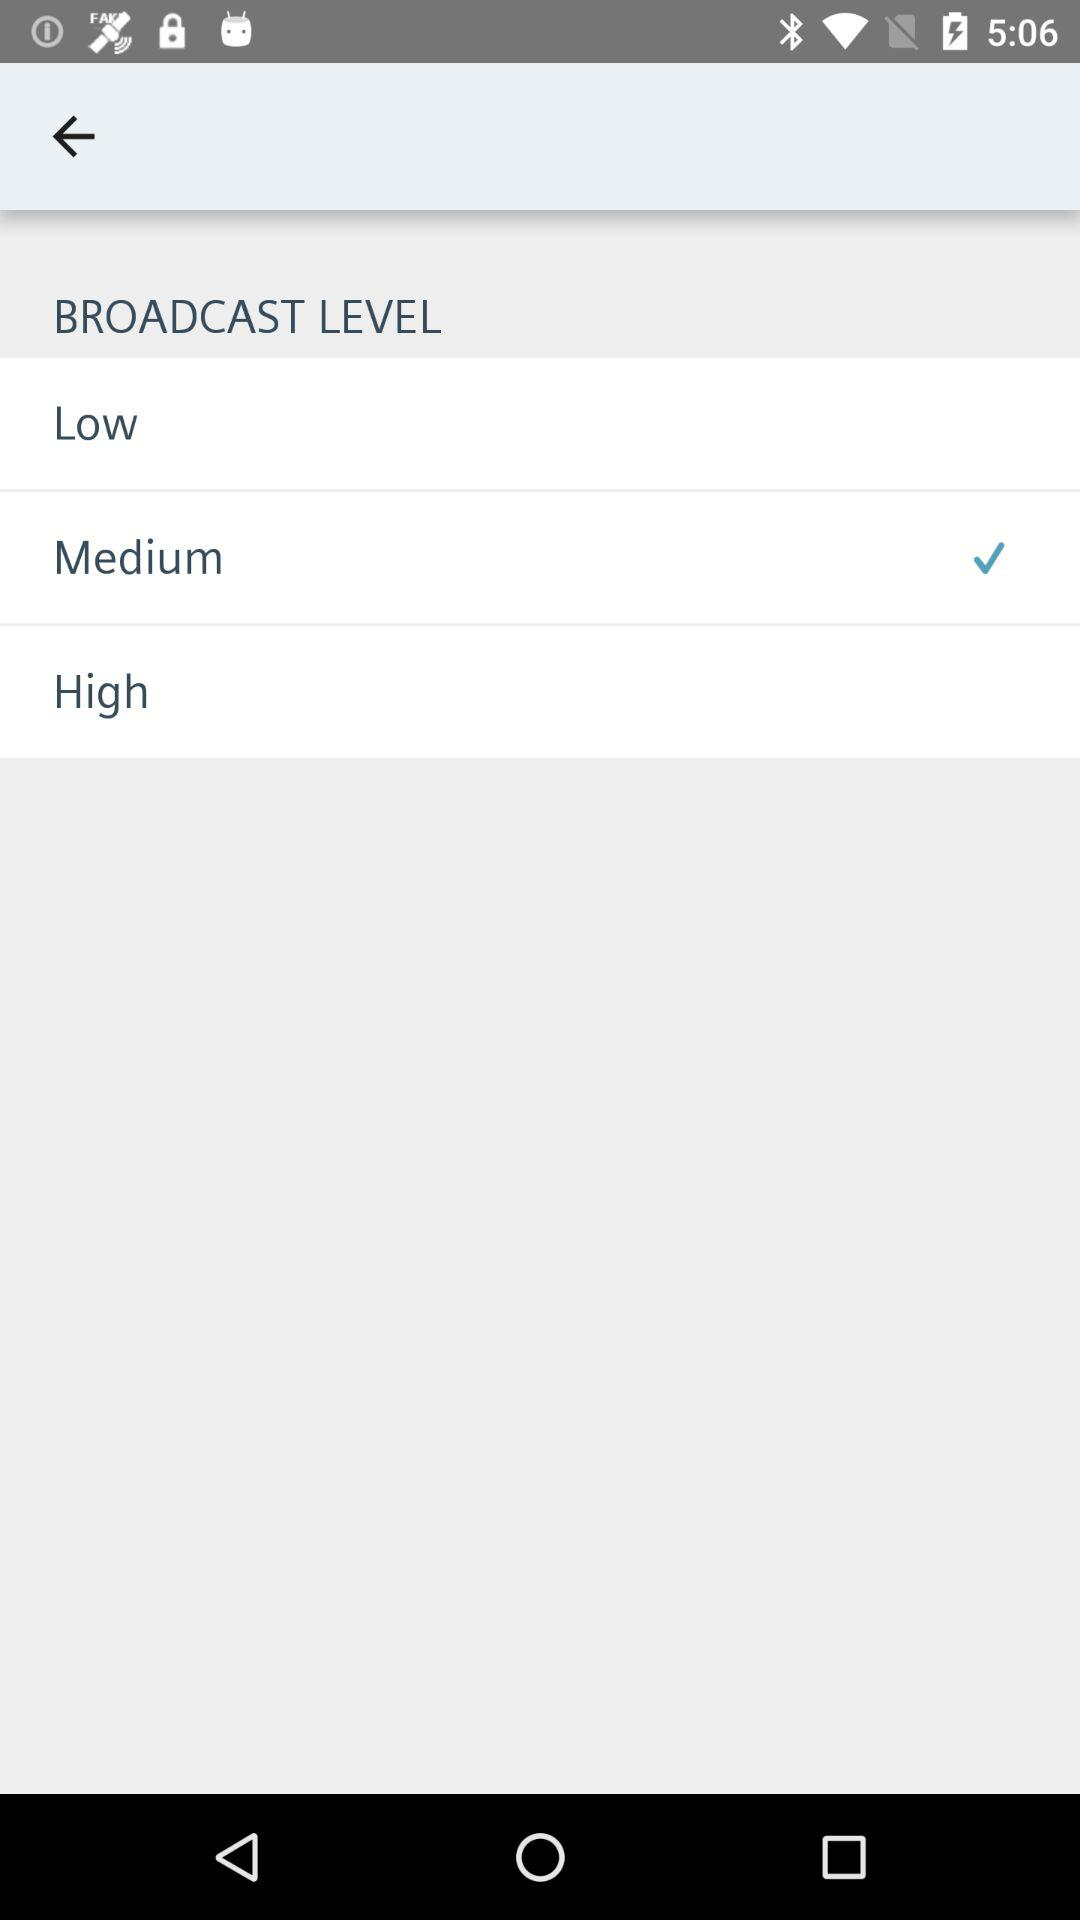What broadcast level is selected? The selected broadcast level is "Medium". 